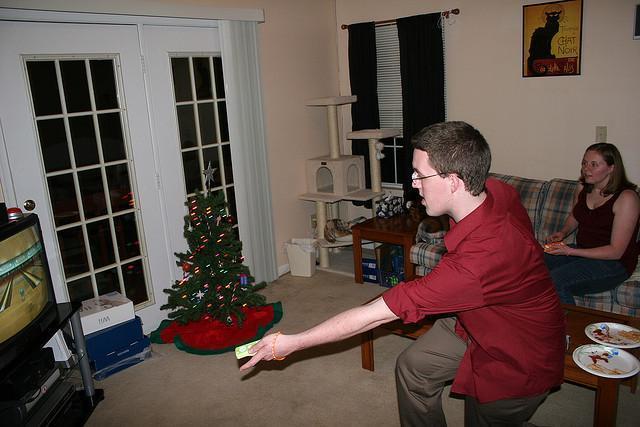What kind of game is the man playing?
Answer the question by selecting the correct answer among the 4 following choices and explain your choice with a short sentence. The answer should be formatted with the following format: `Answer: choice
Rationale: rationale.`
Options: Building, bowling, shooting, dancing. Answer: bowling.
Rationale: The television screen shows a ball and lanes. 